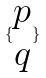<formula> <loc_0><loc_0><loc_500><loc_500>\{ \begin{matrix} p \\ q \end{matrix} \}</formula> 